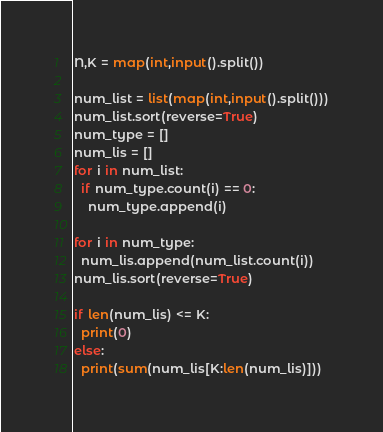Convert code to text. <code><loc_0><loc_0><loc_500><loc_500><_Python_>N,K = map(int,input().split())

num_list = list(map(int,input().split()))
num_list.sort(reverse=True)
num_type = []
num_lis = []
for i in num_list:
  if num_type.count(i) == 0:
    num_type.append(i)

for i in num_type:
  num_lis.append(num_list.count(i))
num_lis.sort(reverse=True)

if len(num_lis) <= K:
  print(0)
else:
  print(sum(num_lis[K:len(num_lis)]))</code> 